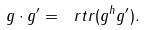<formula> <loc_0><loc_0><loc_500><loc_500>g \cdot g ^ { \prime } = \ r t r ( g ^ { h } g ^ { \prime } ) .</formula> 